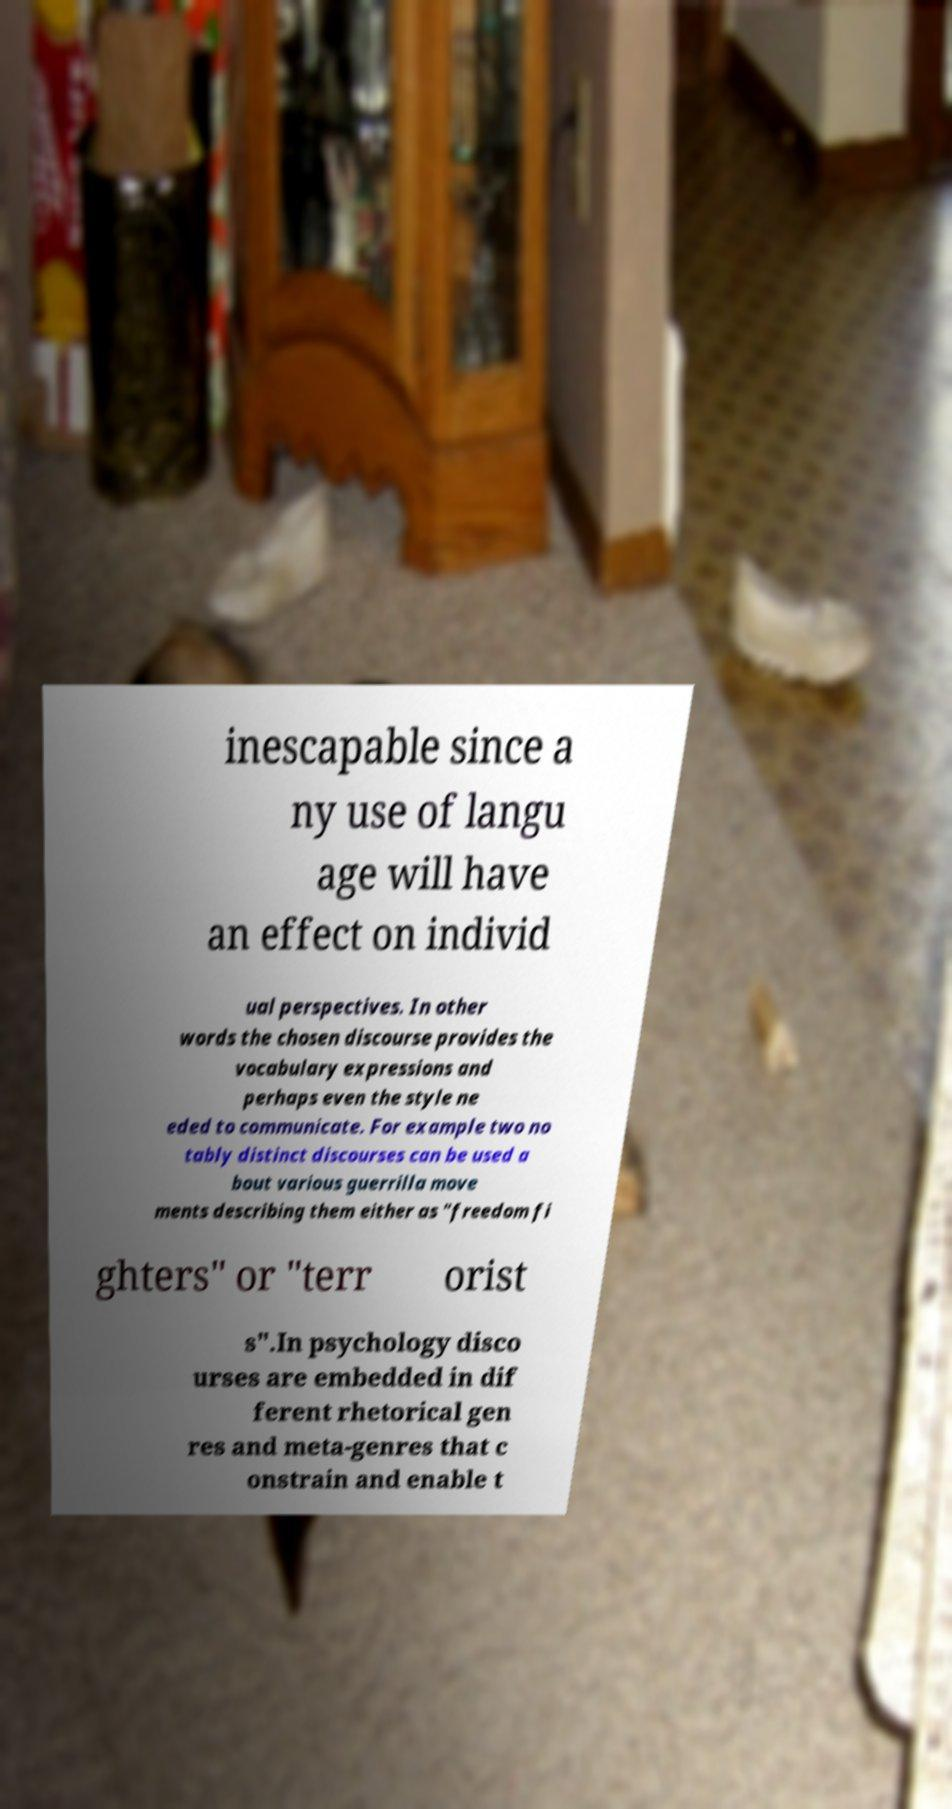Can you read and provide the text displayed in the image?This photo seems to have some interesting text. Can you extract and type it out for me? inescapable since a ny use of langu age will have an effect on individ ual perspectives. In other words the chosen discourse provides the vocabulary expressions and perhaps even the style ne eded to communicate. For example two no tably distinct discourses can be used a bout various guerrilla move ments describing them either as "freedom fi ghters" or "terr orist s".In psychology disco urses are embedded in dif ferent rhetorical gen res and meta-genres that c onstrain and enable t 